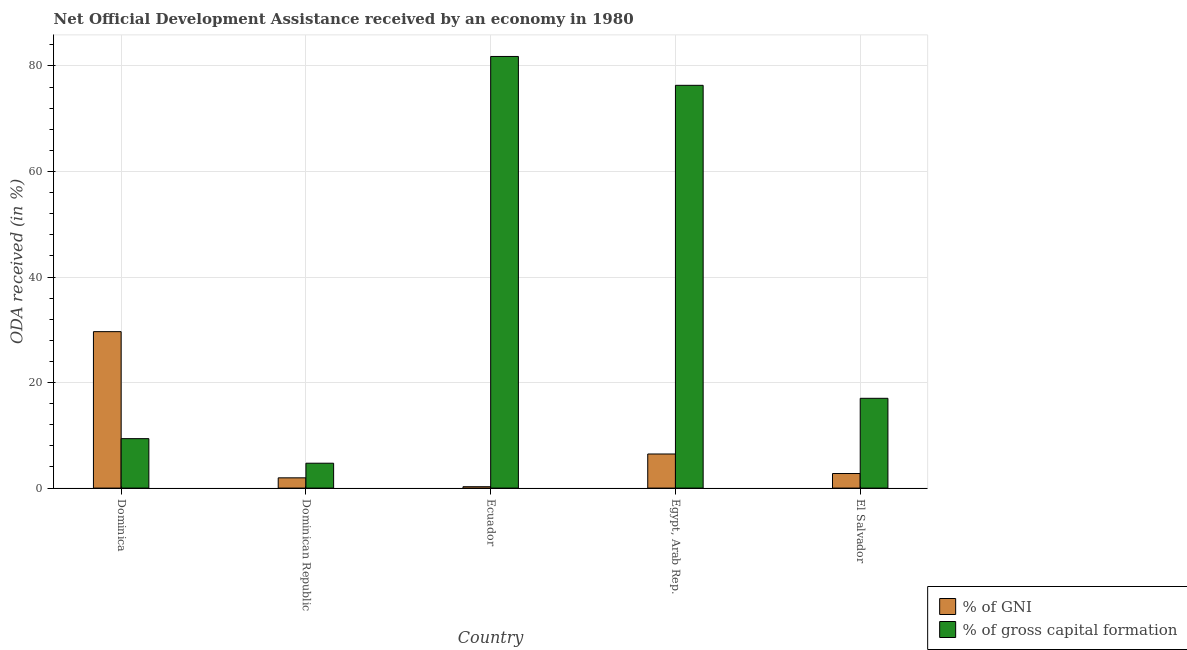How many different coloured bars are there?
Offer a very short reply. 2. How many groups of bars are there?
Your response must be concise. 5. Are the number of bars on each tick of the X-axis equal?
Make the answer very short. Yes. What is the label of the 4th group of bars from the left?
Offer a very short reply. Egypt, Arab Rep. In how many cases, is the number of bars for a given country not equal to the number of legend labels?
Give a very brief answer. 0. What is the oda received as percentage of gni in Dominica?
Ensure brevity in your answer.  29.65. Across all countries, what is the maximum oda received as percentage of gross capital formation?
Your answer should be compact. 81.79. Across all countries, what is the minimum oda received as percentage of gni?
Give a very brief answer. 0.26. In which country was the oda received as percentage of gross capital formation maximum?
Provide a short and direct response. Ecuador. In which country was the oda received as percentage of gni minimum?
Offer a terse response. Ecuador. What is the total oda received as percentage of gross capital formation in the graph?
Make the answer very short. 189.21. What is the difference between the oda received as percentage of gni in Egypt, Arab Rep. and that in El Salvador?
Offer a terse response. 3.7. What is the difference between the oda received as percentage of gross capital formation in Dominica and the oda received as percentage of gni in Dominican Republic?
Keep it short and to the point. 7.43. What is the average oda received as percentage of gni per country?
Provide a short and direct response. 8.21. What is the difference between the oda received as percentage of gross capital formation and oda received as percentage of gni in Dominica?
Keep it short and to the point. -20.28. What is the ratio of the oda received as percentage of gni in Ecuador to that in El Salvador?
Your answer should be very brief. 0.1. Is the oda received as percentage of gross capital formation in Dominica less than that in Ecuador?
Your answer should be very brief. Yes. Is the difference between the oda received as percentage of gross capital formation in Dominican Republic and Egypt, Arab Rep. greater than the difference between the oda received as percentage of gni in Dominican Republic and Egypt, Arab Rep.?
Keep it short and to the point. No. What is the difference between the highest and the second highest oda received as percentage of gross capital formation?
Provide a succinct answer. 5.47. What is the difference between the highest and the lowest oda received as percentage of gni?
Ensure brevity in your answer.  29.38. What does the 1st bar from the left in Ecuador represents?
Keep it short and to the point. % of GNI. What does the 1st bar from the right in Dominican Republic represents?
Make the answer very short. % of gross capital formation. How many countries are there in the graph?
Keep it short and to the point. 5. What is the difference between two consecutive major ticks on the Y-axis?
Make the answer very short. 20. Does the graph contain any zero values?
Your answer should be compact. No. Where does the legend appear in the graph?
Offer a terse response. Bottom right. How many legend labels are there?
Your answer should be very brief. 2. How are the legend labels stacked?
Offer a very short reply. Vertical. What is the title of the graph?
Your answer should be very brief. Net Official Development Assistance received by an economy in 1980. What is the label or title of the X-axis?
Provide a short and direct response. Country. What is the label or title of the Y-axis?
Ensure brevity in your answer.  ODA received (in %). What is the ODA received (in %) of % of GNI in Dominica?
Provide a succinct answer. 29.65. What is the ODA received (in %) of % of gross capital formation in Dominica?
Your answer should be compact. 9.37. What is the ODA received (in %) of % of GNI in Dominican Republic?
Give a very brief answer. 1.94. What is the ODA received (in %) in % of gross capital formation in Dominican Republic?
Ensure brevity in your answer.  4.72. What is the ODA received (in %) of % of GNI in Ecuador?
Provide a succinct answer. 0.26. What is the ODA received (in %) of % of gross capital formation in Ecuador?
Provide a succinct answer. 81.79. What is the ODA received (in %) in % of GNI in Egypt, Arab Rep.?
Offer a very short reply. 6.46. What is the ODA received (in %) of % of gross capital formation in Egypt, Arab Rep.?
Offer a very short reply. 76.32. What is the ODA received (in %) of % of GNI in El Salvador?
Offer a very short reply. 2.76. What is the ODA received (in %) in % of gross capital formation in El Salvador?
Offer a very short reply. 17.01. Across all countries, what is the maximum ODA received (in %) of % of GNI?
Keep it short and to the point. 29.65. Across all countries, what is the maximum ODA received (in %) of % of gross capital formation?
Ensure brevity in your answer.  81.79. Across all countries, what is the minimum ODA received (in %) of % of GNI?
Your response must be concise. 0.26. Across all countries, what is the minimum ODA received (in %) in % of gross capital formation?
Provide a short and direct response. 4.72. What is the total ODA received (in %) of % of GNI in the graph?
Make the answer very short. 41.07. What is the total ODA received (in %) of % of gross capital formation in the graph?
Provide a succinct answer. 189.21. What is the difference between the ODA received (in %) in % of GNI in Dominica and that in Dominican Republic?
Ensure brevity in your answer.  27.7. What is the difference between the ODA received (in %) of % of gross capital formation in Dominica and that in Dominican Republic?
Your answer should be compact. 4.65. What is the difference between the ODA received (in %) in % of GNI in Dominica and that in Ecuador?
Offer a terse response. 29.38. What is the difference between the ODA received (in %) in % of gross capital formation in Dominica and that in Ecuador?
Give a very brief answer. -72.42. What is the difference between the ODA received (in %) in % of GNI in Dominica and that in Egypt, Arab Rep.?
Your response must be concise. 23.18. What is the difference between the ODA received (in %) of % of gross capital formation in Dominica and that in Egypt, Arab Rep.?
Ensure brevity in your answer.  -66.96. What is the difference between the ODA received (in %) in % of GNI in Dominica and that in El Salvador?
Offer a very short reply. 26.89. What is the difference between the ODA received (in %) in % of gross capital formation in Dominica and that in El Salvador?
Give a very brief answer. -7.64. What is the difference between the ODA received (in %) in % of GNI in Dominican Republic and that in Ecuador?
Offer a terse response. 1.68. What is the difference between the ODA received (in %) in % of gross capital formation in Dominican Republic and that in Ecuador?
Ensure brevity in your answer.  -77.08. What is the difference between the ODA received (in %) in % of GNI in Dominican Republic and that in Egypt, Arab Rep.?
Keep it short and to the point. -4.52. What is the difference between the ODA received (in %) of % of gross capital formation in Dominican Republic and that in Egypt, Arab Rep.?
Keep it short and to the point. -71.61. What is the difference between the ODA received (in %) of % of GNI in Dominican Republic and that in El Salvador?
Your answer should be very brief. -0.82. What is the difference between the ODA received (in %) in % of gross capital formation in Dominican Republic and that in El Salvador?
Give a very brief answer. -12.3. What is the difference between the ODA received (in %) of % of GNI in Ecuador and that in Egypt, Arab Rep.?
Provide a short and direct response. -6.2. What is the difference between the ODA received (in %) of % of gross capital formation in Ecuador and that in Egypt, Arab Rep.?
Your answer should be very brief. 5.47. What is the difference between the ODA received (in %) of % of GNI in Ecuador and that in El Salvador?
Your response must be concise. -2.5. What is the difference between the ODA received (in %) of % of gross capital formation in Ecuador and that in El Salvador?
Give a very brief answer. 64.78. What is the difference between the ODA received (in %) in % of GNI in Egypt, Arab Rep. and that in El Salvador?
Ensure brevity in your answer.  3.7. What is the difference between the ODA received (in %) of % of gross capital formation in Egypt, Arab Rep. and that in El Salvador?
Offer a very short reply. 59.31. What is the difference between the ODA received (in %) in % of GNI in Dominica and the ODA received (in %) in % of gross capital formation in Dominican Republic?
Offer a terse response. 24.93. What is the difference between the ODA received (in %) of % of GNI in Dominica and the ODA received (in %) of % of gross capital formation in Ecuador?
Make the answer very short. -52.15. What is the difference between the ODA received (in %) of % of GNI in Dominica and the ODA received (in %) of % of gross capital formation in Egypt, Arab Rep.?
Provide a succinct answer. -46.68. What is the difference between the ODA received (in %) of % of GNI in Dominica and the ODA received (in %) of % of gross capital formation in El Salvador?
Provide a succinct answer. 12.63. What is the difference between the ODA received (in %) of % of GNI in Dominican Republic and the ODA received (in %) of % of gross capital formation in Ecuador?
Make the answer very short. -79.85. What is the difference between the ODA received (in %) of % of GNI in Dominican Republic and the ODA received (in %) of % of gross capital formation in Egypt, Arab Rep.?
Your response must be concise. -74.38. What is the difference between the ODA received (in %) in % of GNI in Dominican Republic and the ODA received (in %) in % of gross capital formation in El Salvador?
Offer a very short reply. -15.07. What is the difference between the ODA received (in %) of % of GNI in Ecuador and the ODA received (in %) of % of gross capital formation in Egypt, Arab Rep.?
Your response must be concise. -76.06. What is the difference between the ODA received (in %) of % of GNI in Ecuador and the ODA received (in %) of % of gross capital formation in El Salvador?
Offer a very short reply. -16.75. What is the difference between the ODA received (in %) of % of GNI in Egypt, Arab Rep. and the ODA received (in %) of % of gross capital formation in El Salvador?
Make the answer very short. -10.55. What is the average ODA received (in %) of % of GNI per country?
Make the answer very short. 8.21. What is the average ODA received (in %) in % of gross capital formation per country?
Make the answer very short. 37.84. What is the difference between the ODA received (in %) in % of GNI and ODA received (in %) in % of gross capital formation in Dominica?
Your answer should be very brief. 20.28. What is the difference between the ODA received (in %) of % of GNI and ODA received (in %) of % of gross capital formation in Dominican Republic?
Give a very brief answer. -2.77. What is the difference between the ODA received (in %) of % of GNI and ODA received (in %) of % of gross capital formation in Ecuador?
Your answer should be compact. -81.53. What is the difference between the ODA received (in %) of % of GNI and ODA received (in %) of % of gross capital formation in Egypt, Arab Rep.?
Provide a short and direct response. -69.86. What is the difference between the ODA received (in %) in % of GNI and ODA received (in %) in % of gross capital formation in El Salvador?
Ensure brevity in your answer.  -14.25. What is the ratio of the ODA received (in %) in % of GNI in Dominica to that in Dominican Republic?
Provide a short and direct response. 15.26. What is the ratio of the ODA received (in %) in % of gross capital formation in Dominica to that in Dominican Republic?
Provide a short and direct response. 1.99. What is the ratio of the ODA received (in %) of % of GNI in Dominica to that in Ecuador?
Make the answer very short. 113. What is the ratio of the ODA received (in %) of % of gross capital formation in Dominica to that in Ecuador?
Keep it short and to the point. 0.11. What is the ratio of the ODA received (in %) in % of GNI in Dominica to that in Egypt, Arab Rep.?
Your answer should be compact. 4.59. What is the ratio of the ODA received (in %) of % of gross capital formation in Dominica to that in Egypt, Arab Rep.?
Your response must be concise. 0.12. What is the ratio of the ODA received (in %) of % of GNI in Dominica to that in El Salvador?
Your answer should be very brief. 10.74. What is the ratio of the ODA received (in %) of % of gross capital formation in Dominica to that in El Salvador?
Keep it short and to the point. 0.55. What is the ratio of the ODA received (in %) in % of GNI in Dominican Republic to that in Ecuador?
Give a very brief answer. 7.41. What is the ratio of the ODA received (in %) of % of gross capital formation in Dominican Republic to that in Ecuador?
Offer a terse response. 0.06. What is the ratio of the ODA received (in %) in % of GNI in Dominican Republic to that in Egypt, Arab Rep.?
Your answer should be compact. 0.3. What is the ratio of the ODA received (in %) of % of gross capital formation in Dominican Republic to that in Egypt, Arab Rep.?
Ensure brevity in your answer.  0.06. What is the ratio of the ODA received (in %) of % of GNI in Dominican Republic to that in El Salvador?
Offer a terse response. 0.7. What is the ratio of the ODA received (in %) in % of gross capital formation in Dominican Republic to that in El Salvador?
Provide a succinct answer. 0.28. What is the ratio of the ODA received (in %) in % of GNI in Ecuador to that in Egypt, Arab Rep.?
Provide a succinct answer. 0.04. What is the ratio of the ODA received (in %) in % of gross capital formation in Ecuador to that in Egypt, Arab Rep.?
Your answer should be compact. 1.07. What is the ratio of the ODA received (in %) of % of GNI in Ecuador to that in El Salvador?
Give a very brief answer. 0.1. What is the ratio of the ODA received (in %) in % of gross capital formation in Ecuador to that in El Salvador?
Provide a short and direct response. 4.81. What is the ratio of the ODA received (in %) of % of GNI in Egypt, Arab Rep. to that in El Salvador?
Your answer should be very brief. 2.34. What is the ratio of the ODA received (in %) in % of gross capital formation in Egypt, Arab Rep. to that in El Salvador?
Ensure brevity in your answer.  4.49. What is the difference between the highest and the second highest ODA received (in %) of % of GNI?
Keep it short and to the point. 23.18. What is the difference between the highest and the second highest ODA received (in %) of % of gross capital formation?
Give a very brief answer. 5.47. What is the difference between the highest and the lowest ODA received (in %) of % of GNI?
Give a very brief answer. 29.38. What is the difference between the highest and the lowest ODA received (in %) of % of gross capital formation?
Provide a short and direct response. 77.08. 